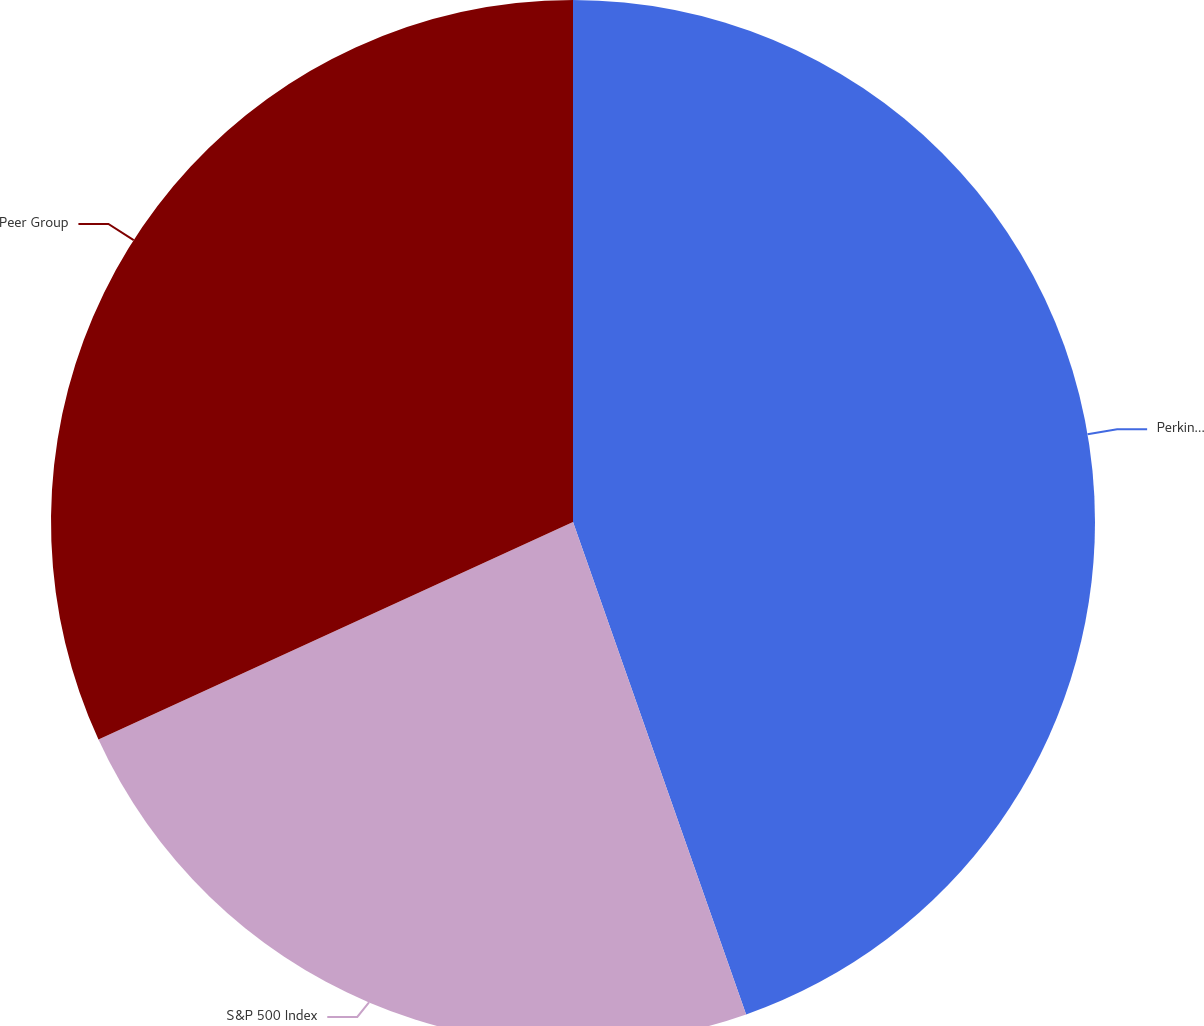Convert chart to OTSL. <chart><loc_0><loc_0><loc_500><loc_500><pie_chart><fcel>PerkinElmer Inc<fcel>S&P 500 Index<fcel>Peer Group<nl><fcel>44.62%<fcel>23.54%<fcel>31.84%<nl></chart> 